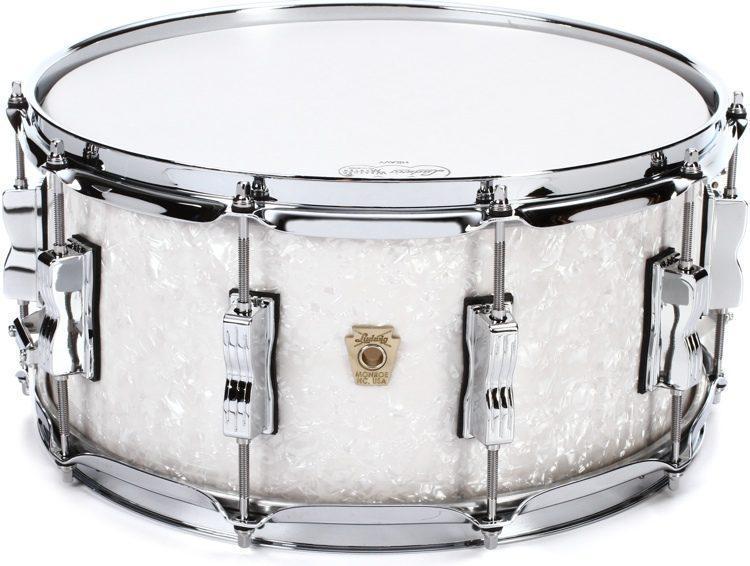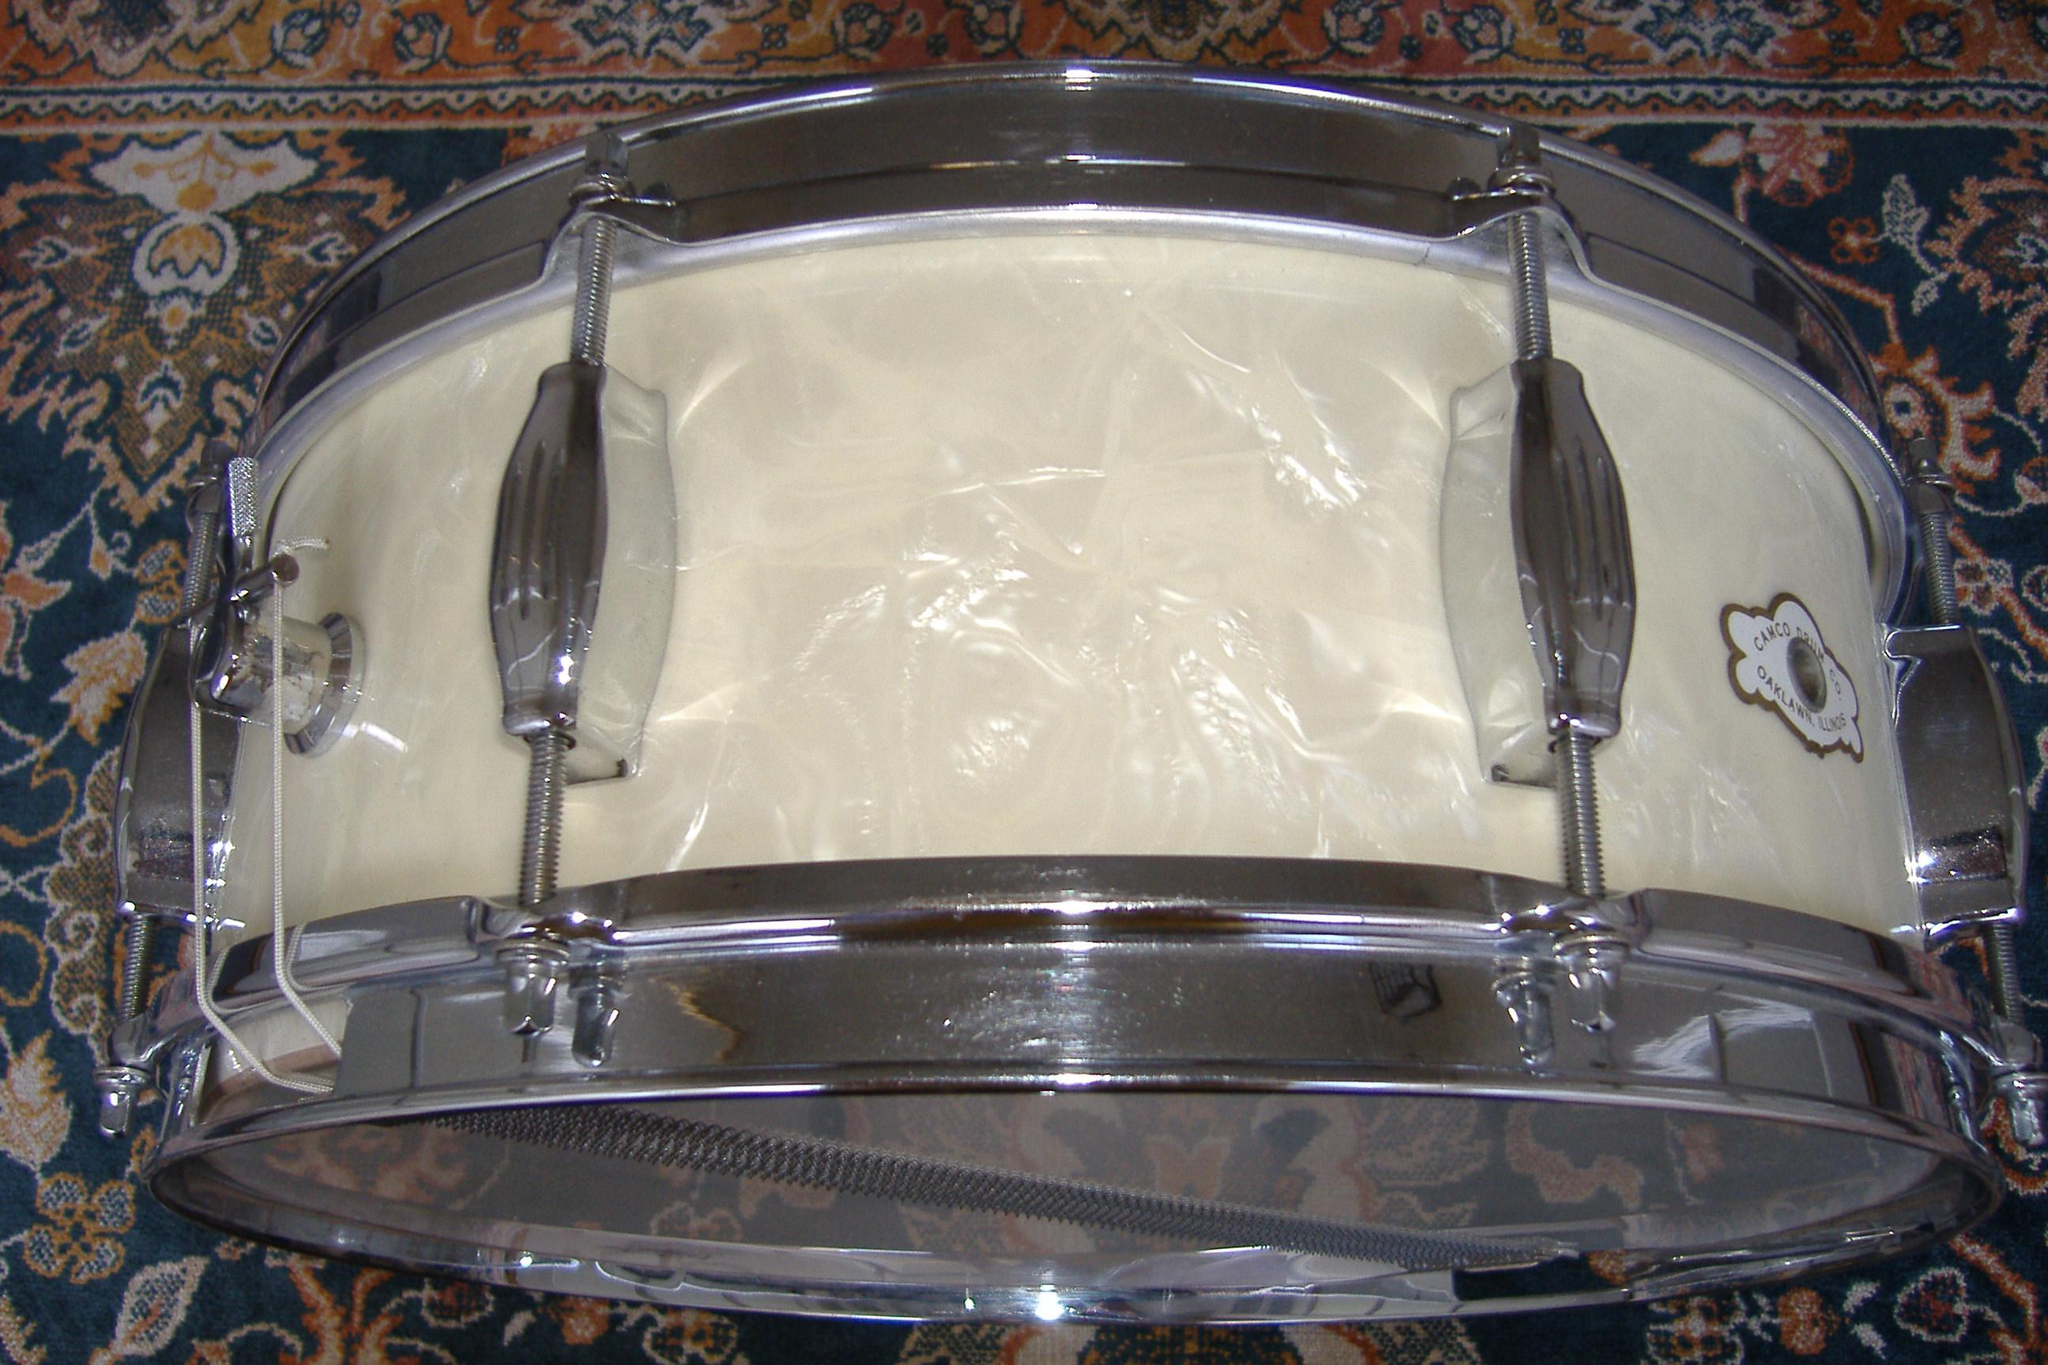The first image is the image on the left, the second image is the image on the right. For the images displayed, is the sentence "The drum on the left is white." factually correct? Answer yes or no. Yes. The first image is the image on the left, the second image is the image on the right. Evaluate the accuracy of this statement regarding the images: "All drums are the same height and are displayed at the same angle, and at least one drum has an oval label centered on the side facing the camera.". Is it true? Answer yes or no. No. 